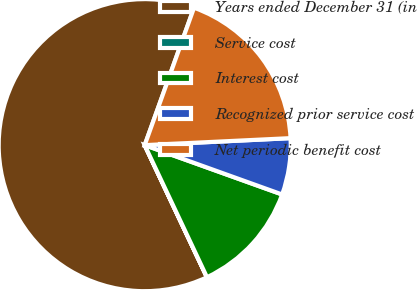Convert chart to OTSL. <chart><loc_0><loc_0><loc_500><loc_500><pie_chart><fcel>Years ended December 31 (in<fcel>Service cost<fcel>Interest cost<fcel>Recognized prior service cost<fcel>Net periodic benefit cost<nl><fcel>62.49%<fcel>0.01%<fcel>12.5%<fcel>6.25%<fcel>18.75%<nl></chart> 